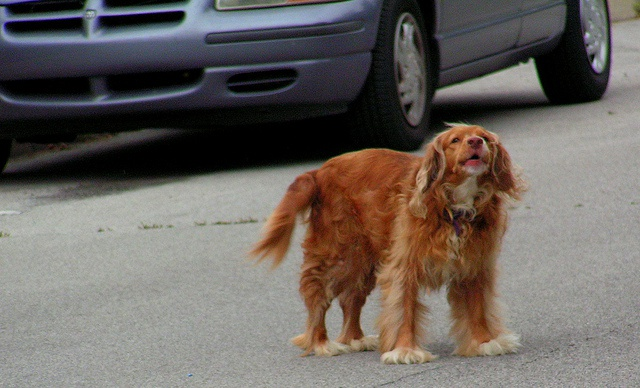Describe the objects in this image and their specific colors. I can see car in gray, black, and darkgray tones and dog in gray, maroon, and brown tones in this image. 